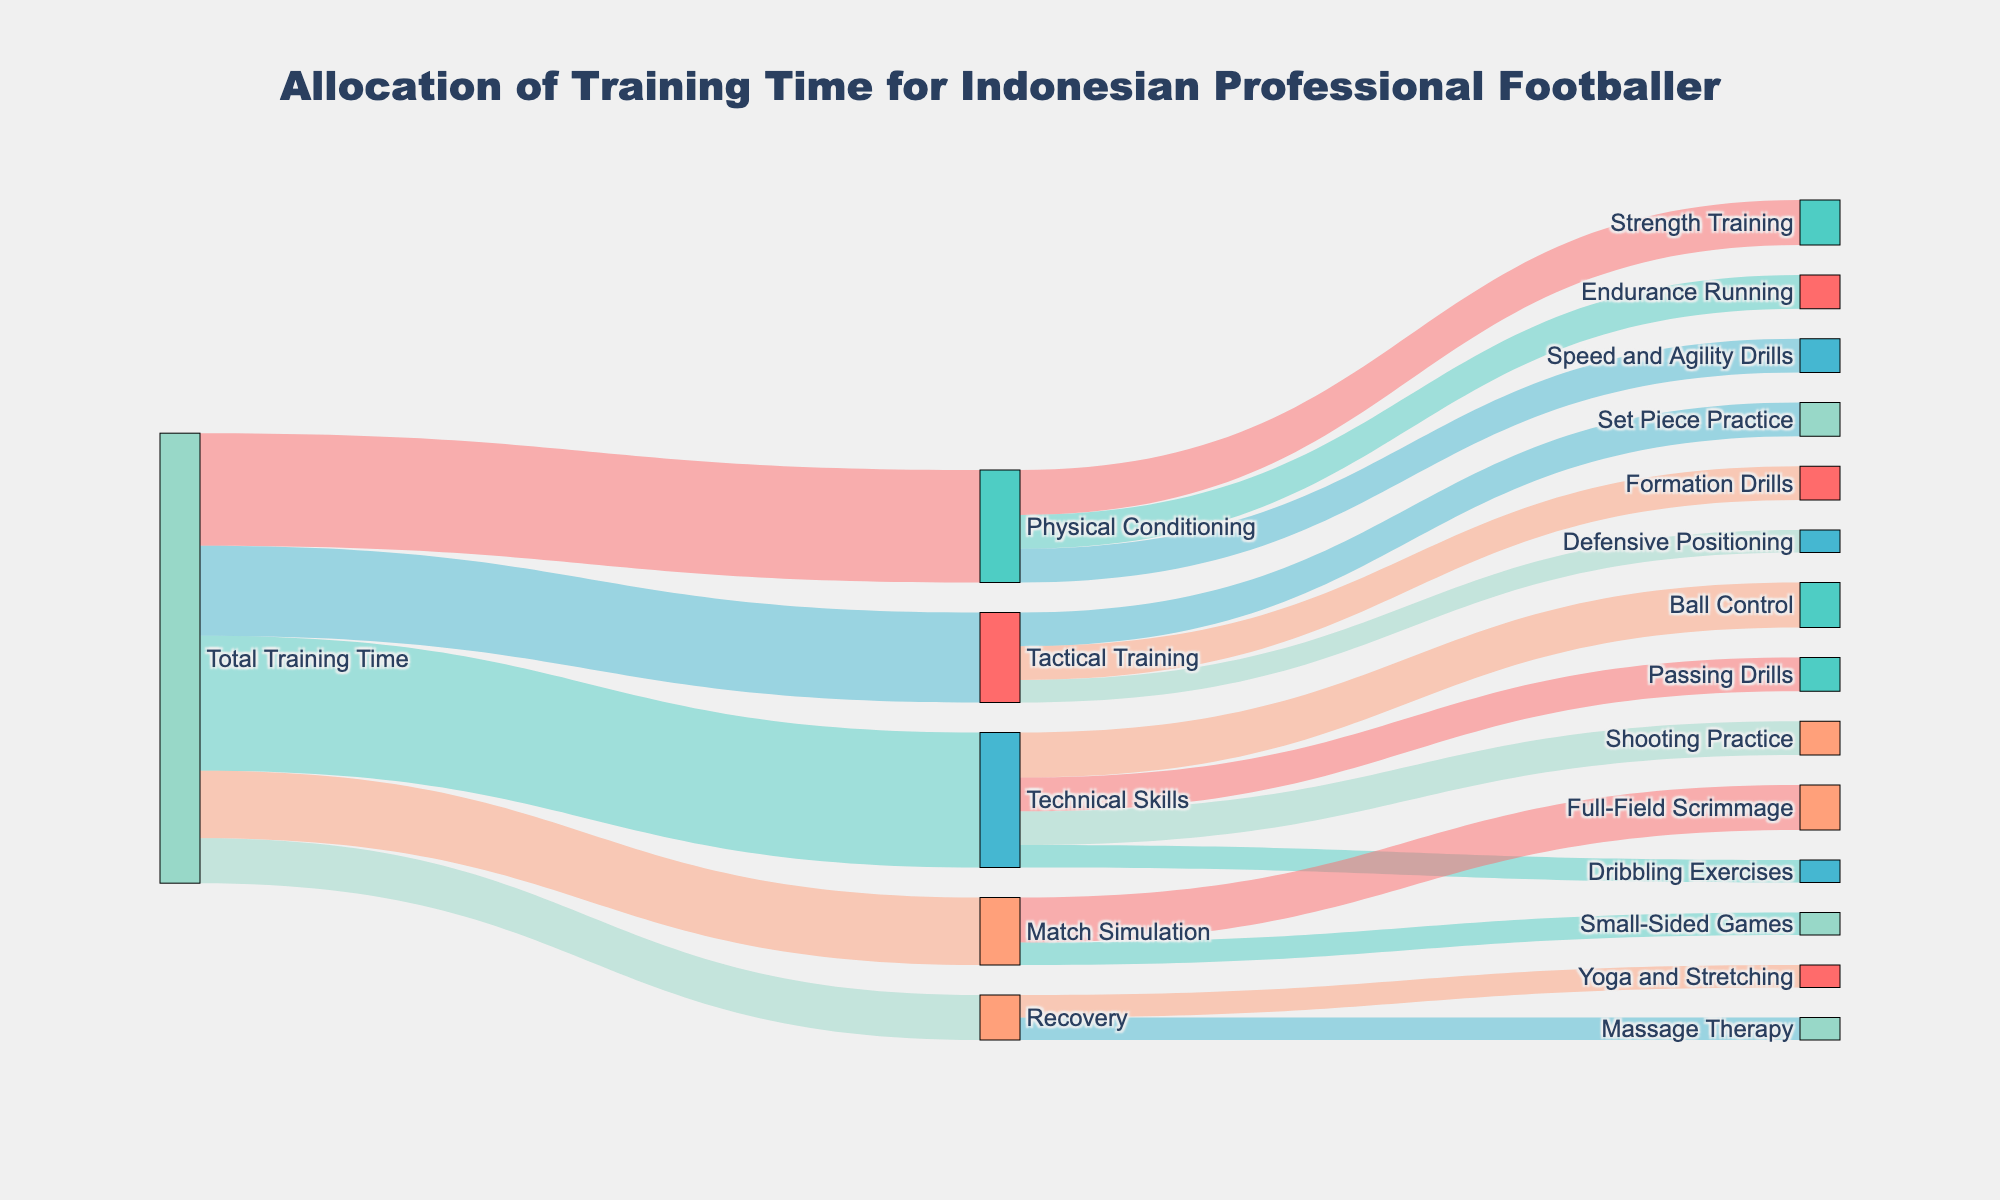What are the different categories of training time allocation seen in the diagram? The diagram shows categories of training time allocation such as Physical Conditioning, Technical Skills, Tactical Training, Match Simulation, and Recovery.
Answer: Physical Conditioning, Technical Skills, Tactical Training, Match Simulation, Recovery How much total training time is allocated to Technical Skills? From the diagram, the value connected from Total Training Time to Technical Skills is 12.
Answer: 12 Which specific activities fall under Technical Skills, and how much time is allocated to each? The Technical Skills category is broken down into Ball Control (4), Shooting Practice (3), Passing Drills (3), and Dribbling Exercises (2).
Answer: Ball Control (4), Shooting Practice (3), Passing Drills (3), Dribbling Exercises (2) What is the total time allocated to Physical Conditioning, and how is it distributed among different activities? Physical Conditioning has a total of 10, distributed as Strength Training (4), Endurance Running (3), and Speed and Agility Drills (3). Adding these values together confirms they sum up to Physical Conditioning's total time.
Answer: 10 (Strength Training: 4, Endurance Running: 3, Speed and Agility Drills: 3) What activity within Tactical Training uses the most time? Set Piece Practice and Formation Drills each use 3, which is the highest amount within Tactical Training.
Answer: Set Piece Practice, Formation Drills Compare the training time allocated to Match Simulation and Recovery. Which receives more time? Match Simulation receives 6 while Recovery receives 4. Therefore, Match Simulation receives more time.
Answer: Match Simulation How much time is allocated to Speed and Agility Drills and how does it compare to the time allocated to Body Conditioning? Speed and Agility Drills have 3, while the total for Physical Conditioning is 10. Speed and Agility Drills is a part of Physical Conditioning but less than the total allocated.
Answer: 3 (less than total Physical Conditioning time) What is the total amount of time allocated to Recovery activities, and how is it distributed? Recovery has a total of 4, distributed equally between Massage Therapy (2) and Yoga and Stretching (2).
Answer: 4 (Massage Therapy: 2, Yoga and Stretching: 2) Which category is allocated the least amount of total training time, and how much is it? Recovery is allocated the least amount of total training time with a value of 4.
Answer: Recovery (4) Which specific activity uses the least amount of time in the whole training schedule? Dribbling Exercises and Yoga and Stretching both use 2 and are the smallest individual activities.
Answer: Dribbling Exercises, Yoga and Stretching 